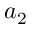Convert formula to latex. <formula><loc_0><loc_0><loc_500><loc_500>a _ { 2 }</formula> 